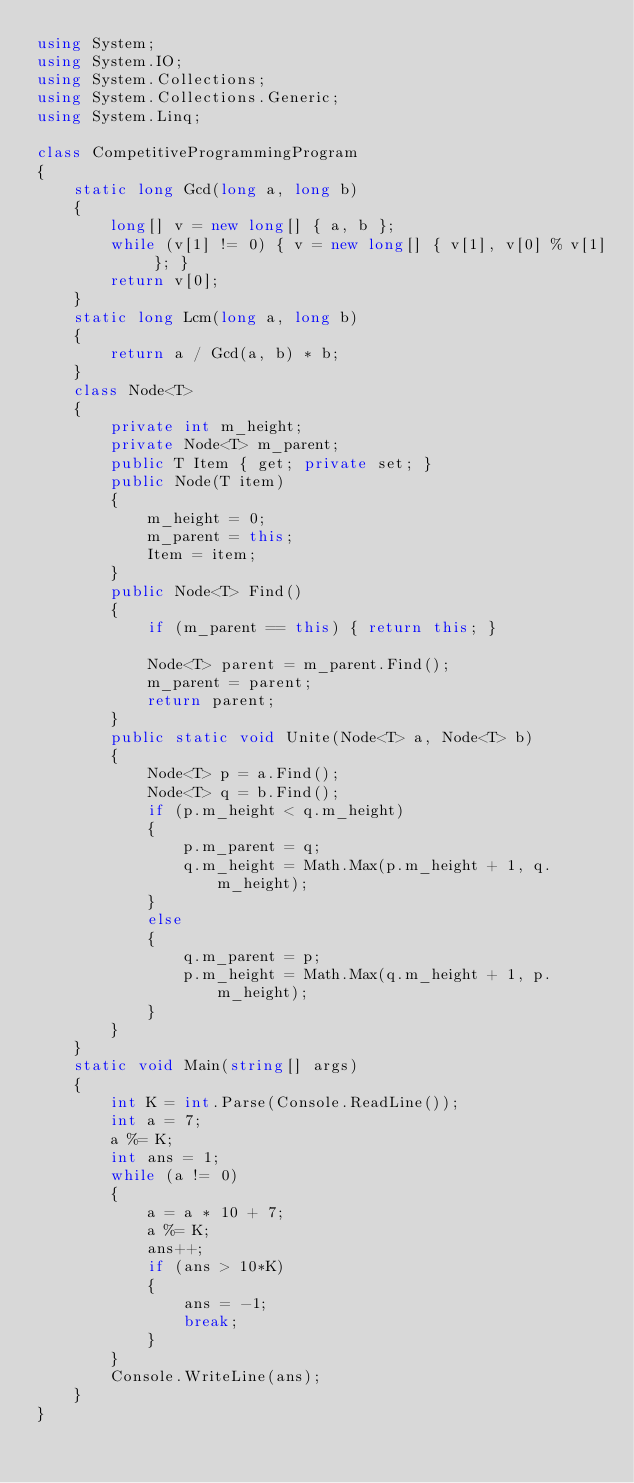<code> <loc_0><loc_0><loc_500><loc_500><_C#_>using System;
using System.IO;
using System.Collections;
using System.Collections.Generic;
using System.Linq;

class CompetitiveProgrammingProgram
{
    static long Gcd(long a, long b)
    {
        long[] v = new long[] { a, b };
        while (v[1] != 0) { v = new long[] { v[1], v[0] % v[1] }; }
        return v[0];
    }
    static long Lcm(long a, long b)
    {
        return a / Gcd(a, b) * b;
    }
    class Node<T>
    {
        private int m_height;
        private Node<T> m_parent;
        public T Item { get; private set; }
        public Node(T item)
        {
            m_height = 0;
            m_parent = this;
            Item = item;
        }
        public Node<T> Find()
        {
            if (m_parent == this) { return this; }

            Node<T> parent = m_parent.Find();
            m_parent = parent;
            return parent;
        }
        public static void Unite(Node<T> a, Node<T> b)
        {
            Node<T> p = a.Find();
            Node<T> q = b.Find();
            if (p.m_height < q.m_height)
            {
                p.m_parent = q;
                q.m_height = Math.Max(p.m_height + 1, q.m_height);
            }
            else
            {
                q.m_parent = p;
                p.m_height = Math.Max(q.m_height + 1, p.m_height);
            }
        }
    }
    static void Main(string[] args)
    {
        int K = int.Parse(Console.ReadLine());
        int a = 7;
        a %= K;
        int ans = 1;
        while (a != 0)
        {
            a = a * 10 + 7;
            a %= K;
            ans++;
            if (ans > 10*K)
            {
                ans = -1;
                break;
            }
        }
        Console.WriteLine(ans);
    }
}</code> 